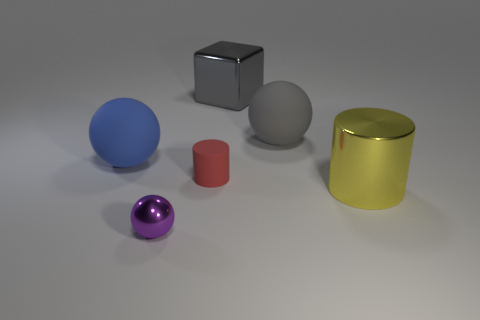Do the small metal object and the shiny block have the same color?
Keep it short and to the point. No. There is a metallic thing that is both on the left side of the large cylinder and in front of the small matte cylinder; what color is it?
Your response must be concise. Purple. There is a gray object that is to the left of the gray sphere; does it have the same size as the small purple thing?
Provide a short and direct response. No. Are there any other things that have the same shape as the tiny purple metallic thing?
Ensure brevity in your answer.  Yes. Does the red cylinder have the same material as the cylinder that is to the right of the red thing?
Ensure brevity in your answer.  No. What number of gray objects are cylinders or small metal objects?
Offer a terse response. 0. Are there any yellow metallic objects?
Ensure brevity in your answer.  Yes. Is there a yellow object that is on the right side of the gray object right of the metallic object that is behind the large gray sphere?
Give a very brief answer. Yes. Is there any other thing that has the same size as the blue rubber sphere?
Your response must be concise. Yes. There is a red thing; is it the same shape as the thing that is in front of the large yellow thing?
Provide a short and direct response. No. 